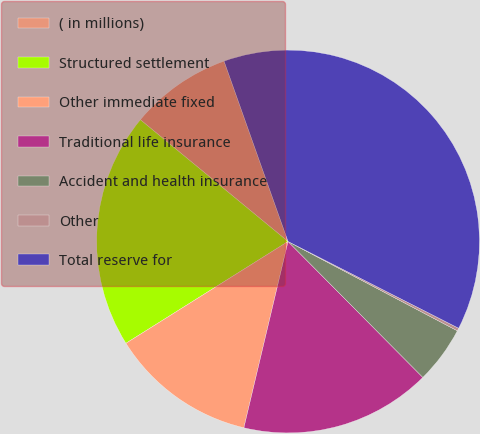<chart> <loc_0><loc_0><loc_500><loc_500><pie_chart><fcel>( in millions)<fcel>Structured settlement<fcel>Other immediate fixed<fcel>Traditional life insurance<fcel>Accident and health insurance<fcel>Other<fcel>Total reserve for<nl><fcel>8.6%<fcel>19.9%<fcel>12.37%<fcel>16.14%<fcel>4.84%<fcel>0.24%<fcel>37.91%<nl></chart> 